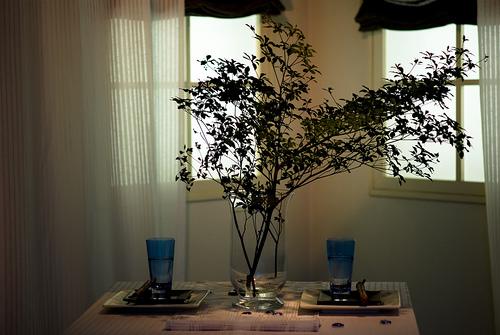What is that light green object sitting on the counter?
Give a very brief answer. Plant. What color are the glasses?
Concise answer only. Blue. Are flowers in the vase?
Be succinct. No. How many placemats are there?
Short answer required. 2. How many windows are shown?
Write a very short answer. 2. Is this bloom a summer-blooming variety?
Give a very brief answer. No. What is seen outside the window?
Be succinct. Nothing. Are the vases the same color?
Short answer required. Yes. What shape is the container holding the flowers?
Keep it brief. Cylinder. Do the flowers appear to be real or fake?
Answer briefly. Real. Is this plant growing?
Answer briefly. Yes. How many glasses are there?
Concise answer only. 2. Can you see a mountain in the picture?
Quick response, please. No. How many cups are there?
Quick response, please. 2. 